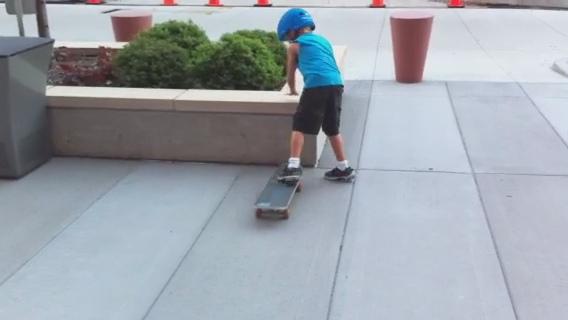What sport is this little kid playing?
Quick response, please. Skateboarding. What plant is in the photo?
Short answer required. Bushes. What does the child have on his head?
Give a very brief answer. Helmet. What style of hat is the man wearing?
Be succinct. Helmet. 